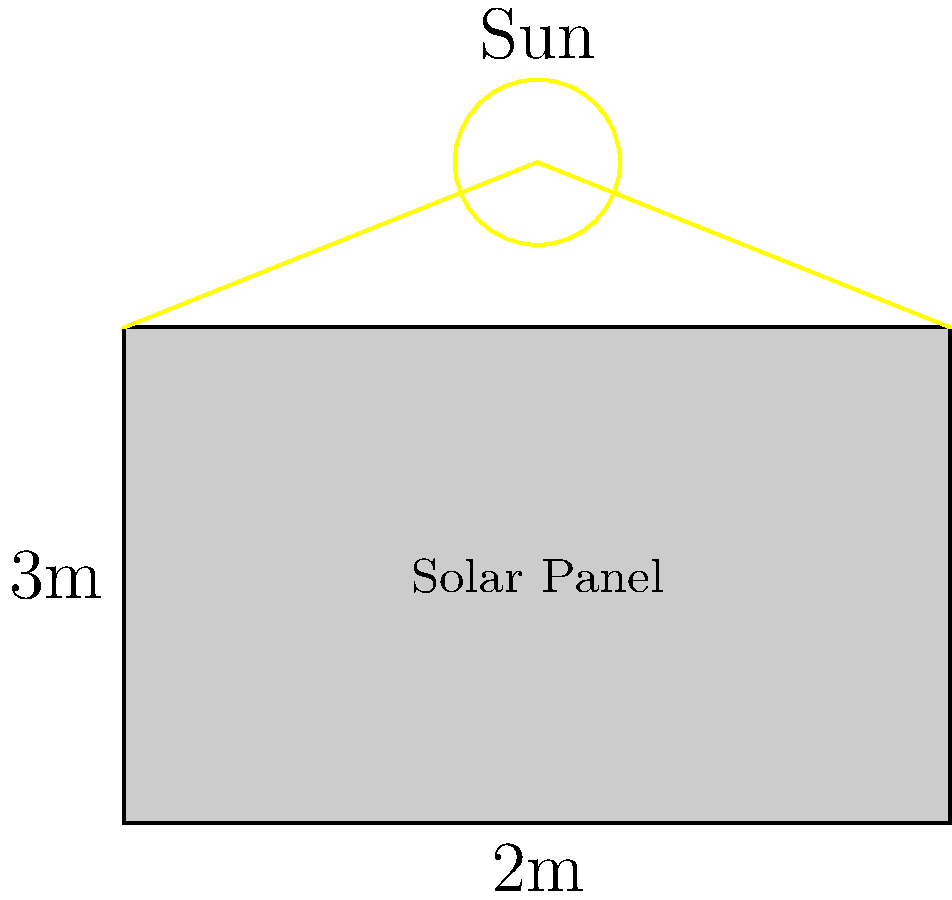As a former footballer, you've been asked to help install solar panels on your local stadium in Bandung. The solar panel measures 2 meters by 3 meters and receives sunlight with an intensity of 1000 W/m². If the panel's efficiency is 15%, what is its power output in watts? To calculate the power output of the solar panel, we need to follow these steps:

1. Calculate the area of the solar panel:
   Area $= \text{length} \times \text{width} = 2 \text{ m} \times 3 \text{ m} = 6 \text{ m}^2$

2. Calculate the total solar power incident on the panel:
   Incident power $= \text{area} \times \text{sunlight intensity}$
   $= 6 \text{ m}^2 \times 1000 \text{ W/m}^2 = 6000 \text{ W}$

3. Calculate the power output considering the panel's efficiency:
   Power output $= \text{incident power} \times \text{efficiency}$
   $= 6000 \text{ W} \times 0.15 = 900 \text{ W}$

Therefore, the power output of the solar panel is 900 watts.
Answer: 900 W 